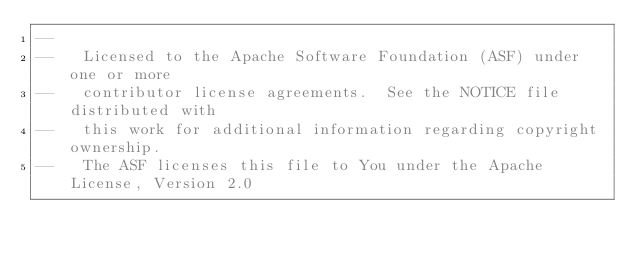Convert code to text. <code><loc_0><loc_0><loc_500><loc_500><_SQL_>--
--   Licensed to the Apache Software Foundation (ASF) under one or more
--   contributor license agreements.  See the NOTICE file distributed with
--   this work for additional information regarding copyright ownership.
--   The ASF licenses this file to You under the Apache License, Version 2.0</code> 